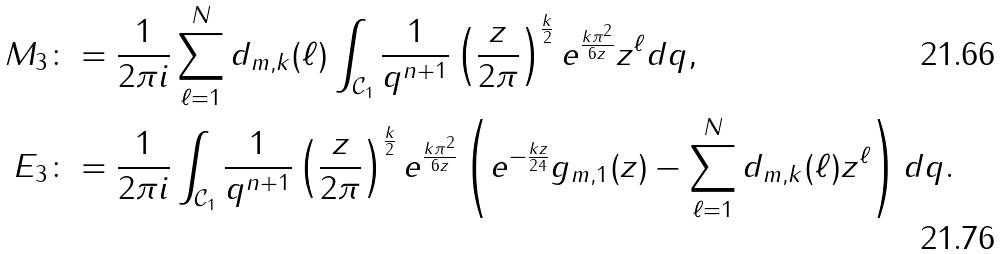<formula> <loc_0><loc_0><loc_500><loc_500>M _ { 3 } & \colon = \frac { 1 } { 2 \pi i } \sum _ { \ell = 1 } ^ { N } d _ { m , k } ( \ell ) \int _ { \mathcal { C } _ { 1 } } \frac { 1 } { q ^ { n + 1 } } \left ( \frac { z } { 2 \pi } \right ) ^ { \frac { k } { 2 } } e ^ { \frac { k \pi ^ { 2 } } { 6 z } } z ^ { \ell } d q , \\ E _ { 3 } & \colon = \frac { 1 } { 2 \pi i } \int _ { \mathcal { C } _ { 1 } } \frac { 1 } { q ^ { n + 1 } } \left ( \frac { z } { 2 \pi } \right ) ^ { \frac { k } { 2 } } e ^ { \frac { k \pi ^ { 2 } } { 6 z } } \left ( e ^ { - \frac { k z } { 2 4 } } g _ { m , 1 } ( z ) - \sum _ { \ell = 1 } ^ { N } d _ { m , k } ( \ell ) z ^ { \ell } \right ) d q .</formula> 